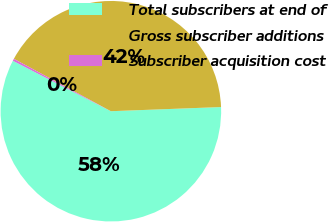Convert chart. <chart><loc_0><loc_0><loc_500><loc_500><pie_chart><fcel>Total subscribers at end of<fcel>Gross subscriber additions<fcel>Subscriber acquisition cost<nl><fcel>58.16%<fcel>41.52%<fcel>0.32%<nl></chart> 